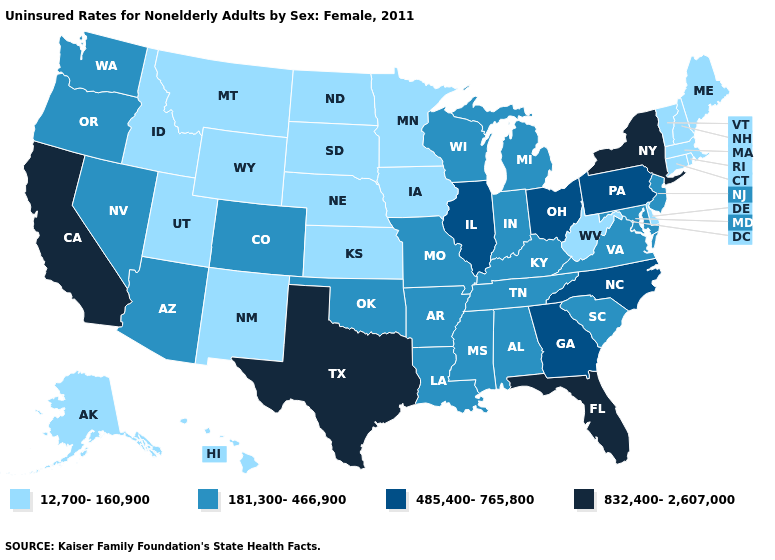What is the highest value in states that border Washington?
Keep it brief. 181,300-466,900. Does Mississippi have the highest value in the South?
Concise answer only. No. What is the highest value in states that border Massachusetts?
Short answer required. 832,400-2,607,000. Does Maine have the lowest value in the USA?
Short answer required. Yes. What is the value of Oregon?
Concise answer only. 181,300-466,900. Which states hav the highest value in the MidWest?
Short answer required. Illinois, Ohio. Name the states that have a value in the range 181,300-466,900?
Answer briefly. Alabama, Arizona, Arkansas, Colorado, Indiana, Kentucky, Louisiana, Maryland, Michigan, Mississippi, Missouri, Nevada, New Jersey, Oklahoma, Oregon, South Carolina, Tennessee, Virginia, Washington, Wisconsin. What is the value of Virginia?
Short answer required. 181,300-466,900. How many symbols are there in the legend?
Keep it brief. 4. Does Florida have the highest value in the USA?
Write a very short answer. Yes. Among the states that border Oklahoma , which have the highest value?
Answer briefly. Texas. What is the value of South Carolina?
Short answer required. 181,300-466,900. Does the map have missing data?
Quick response, please. No. Does the first symbol in the legend represent the smallest category?
Give a very brief answer. Yes. Does Florida have the highest value in the USA?
Give a very brief answer. Yes. 